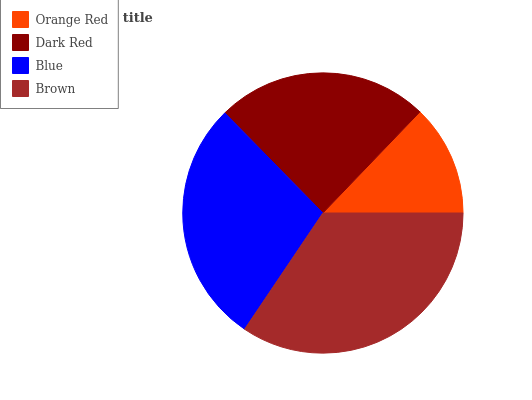Is Orange Red the minimum?
Answer yes or no. Yes. Is Brown the maximum?
Answer yes or no. Yes. Is Dark Red the minimum?
Answer yes or no. No. Is Dark Red the maximum?
Answer yes or no. No. Is Dark Red greater than Orange Red?
Answer yes or no. Yes. Is Orange Red less than Dark Red?
Answer yes or no. Yes. Is Orange Red greater than Dark Red?
Answer yes or no. No. Is Dark Red less than Orange Red?
Answer yes or no. No. Is Blue the high median?
Answer yes or no. Yes. Is Dark Red the low median?
Answer yes or no. Yes. Is Brown the high median?
Answer yes or no. No. Is Blue the low median?
Answer yes or no. No. 